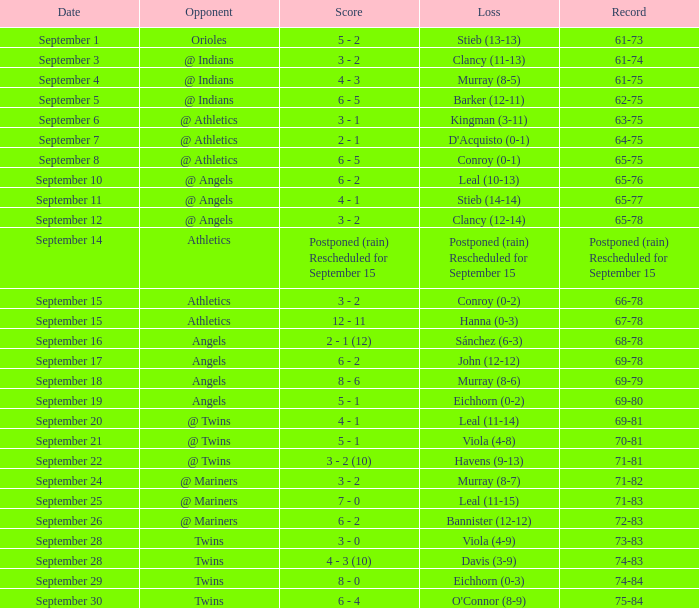Name the date for record of 74-84 September 29. 